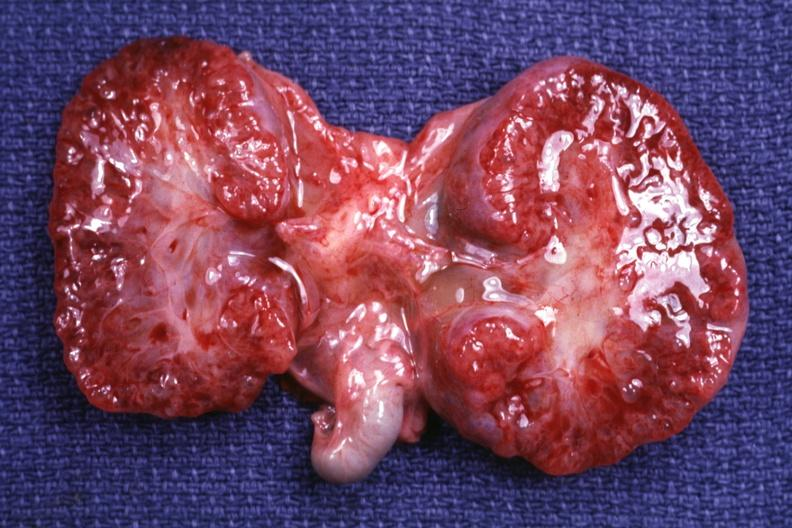where is this?
Answer the question using a single word or phrase. Urinary 